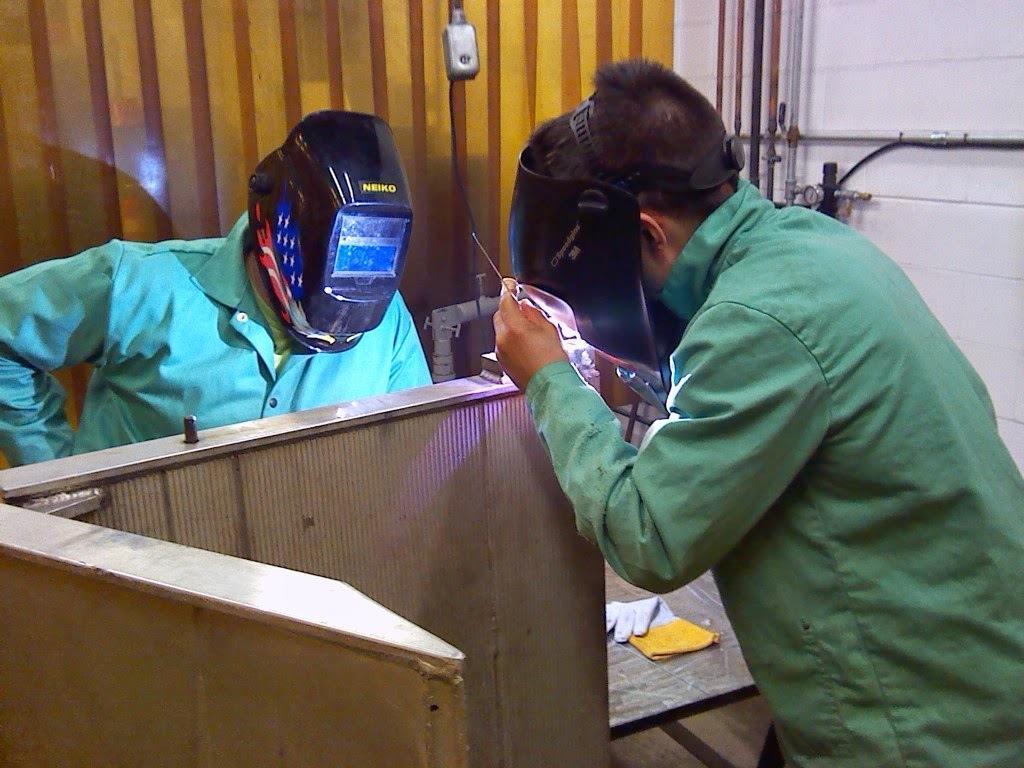Describe this image in one or two sentences. In this picture there is a person standing and holding the object and there is a person standing and there is a wooden object. At the bottom there is a glove. At the back there are pipes on the wall. 